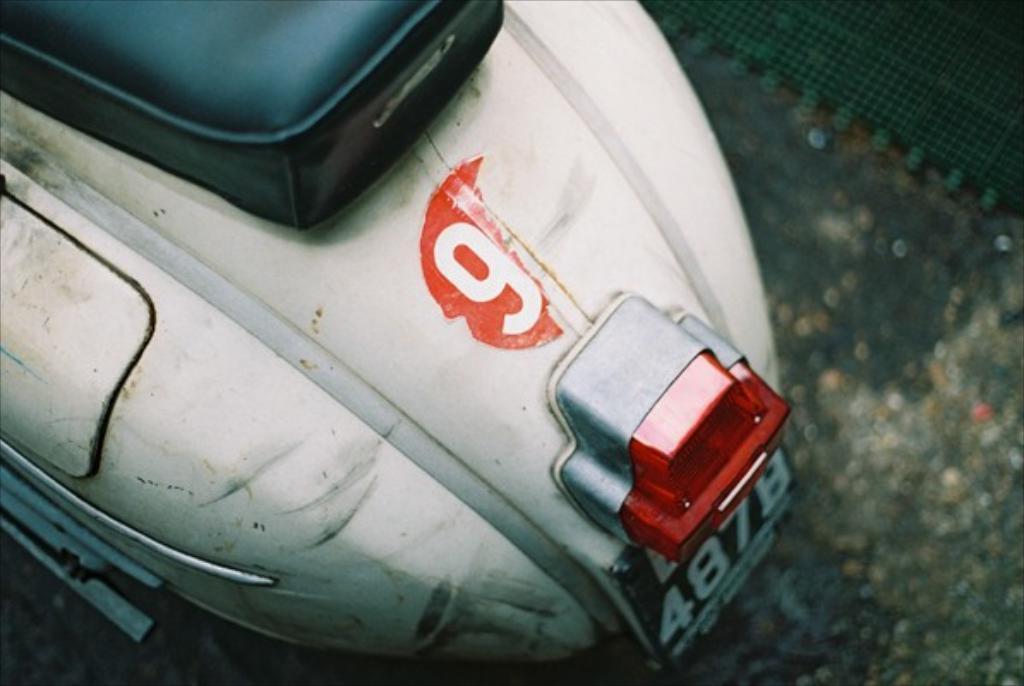How would you summarize this image in a sentence or two? In this image in front there is a scooter on the road. 